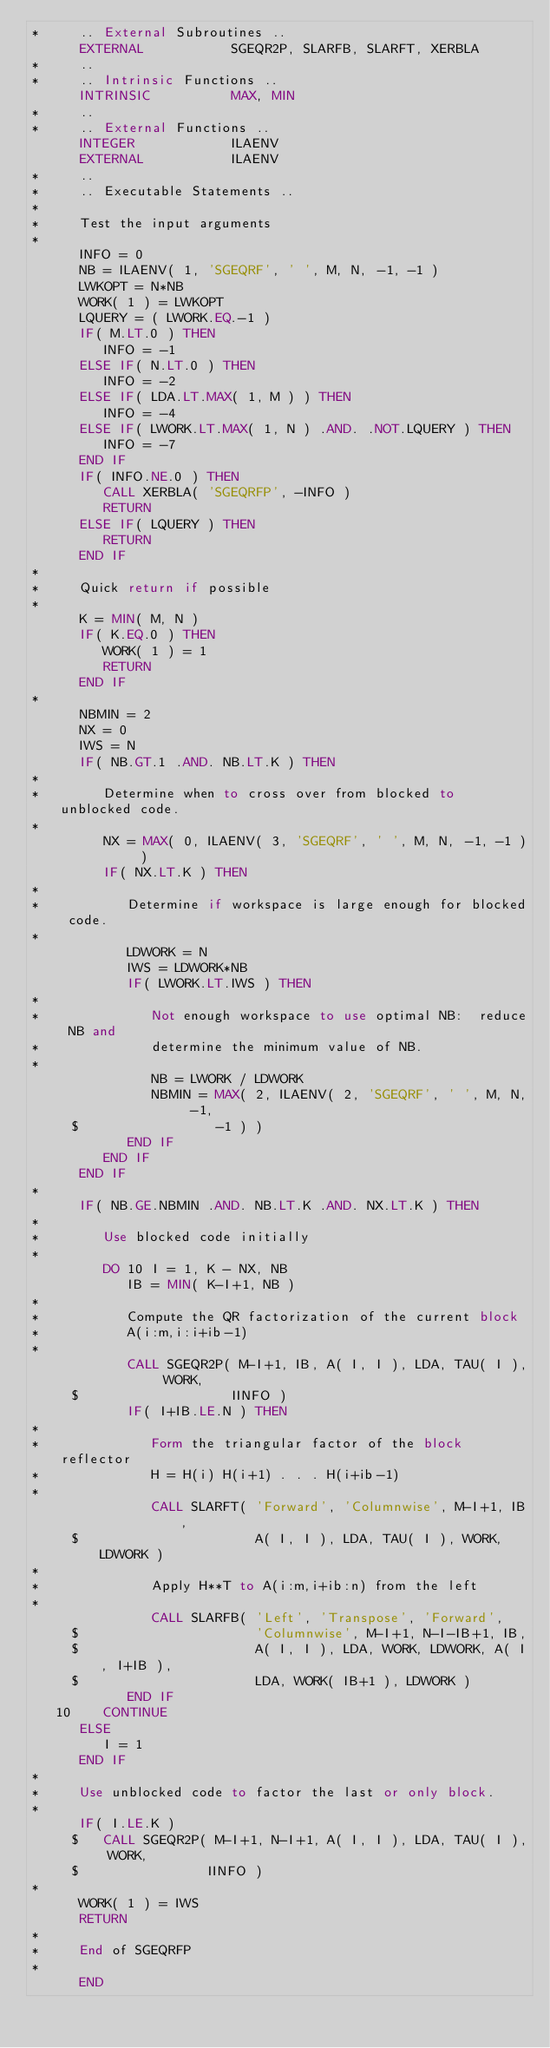<code> <loc_0><loc_0><loc_500><loc_500><_FORTRAN_>*     .. External Subroutines ..
      EXTERNAL           SGEQR2P, SLARFB, SLARFT, XERBLA
*     ..
*     .. Intrinsic Functions ..
      INTRINSIC          MAX, MIN
*     ..
*     .. External Functions ..
      INTEGER            ILAENV
      EXTERNAL           ILAENV
*     ..
*     .. Executable Statements ..
*
*     Test the input arguments
*
      INFO = 0
      NB = ILAENV( 1, 'SGEQRF', ' ', M, N, -1, -1 )
      LWKOPT = N*NB
      WORK( 1 ) = LWKOPT
      LQUERY = ( LWORK.EQ.-1 )
      IF( M.LT.0 ) THEN
         INFO = -1
      ELSE IF( N.LT.0 ) THEN
         INFO = -2
      ELSE IF( LDA.LT.MAX( 1, M ) ) THEN
         INFO = -4
      ELSE IF( LWORK.LT.MAX( 1, N ) .AND. .NOT.LQUERY ) THEN
         INFO = -7
      END IF
      IF( INFO.NE.0 ) THEN
         CALL XERBLA( 'SGEQRFP', -INFO )
         RETURN
      ELSE IF( LQUERY ) THEN
         RETURN
      END IF
*
*     Quick return if possible
*
      K = MIN( M, N )
      IF( K.EQ.0 ) THEN
         WORK( 1 ) = 1
         RETURN
      END IF
*
      NBMIN = 2
      NX = 0
      IWS = N
      IF( NB.GT.1 .AND. NB.LT.K ) THEN
*
*        Determine when to cross over from blocked to unblocked code.
*
         NX = MAX( 0, ILAENV( 3, 'SGEQRF', ' ', M, N, -1, -1 ) )
         IF( NX.LT.K ) THEN
*
*           Determine if workspace is large enough for blocked code.
*
            LDWORK = N
            IWS = LDWORK*NB
            IF( LWORK.LT.IWS ) THEN
*
*              Not enough workspace to use optimal NB:  reduce NB and
*              determine the minimum value of NB.
*
               NB = LWORK / LDWORK
               NBMIN = MAX( 2, ILAENV( 2, 'SGEQRF', ' ', M, N, -1,
     $                 -1 ) )
            END IF
         END IF
      END IF
*
      IF( NB.GE.NBMIN .AND. NB.LT.K .AND. NX.LT.K ) THEN
*
*        Use blocked code initially
*
         DO 10 I = 1, K - NX, NB
            IB = MIN( K-I+1, NB )
*
*           Compute the QR factorization of the current block
*           A(i:m,i:i+ib-1)
*
            CALL SGEQR2P( M-I+1, IB, A( I, I ), LDA, TAU( I ), WORK,
     $                   IINFO )
            IF( I+IB.LE.N ) THEN
*
*              Form the triangular factor of the block reflector
*              H = H(i) H(i+1) . . . H(i+ib-1)
*
               CALL SLARFT( 'Forward', 'Columnwise', M-I+1, IB,
     $                      A( I, I ), LDA, TAU( I ), WORK, LDWORK )
*
*              Apply H**T to A(i:m,i+ib:n) from the left
*
               CALL SLARFB( 'Left', 'Transpose', 'Forward',
     $                      'Columnwise', M-I+1, N-I-IB+1, IB,
     $                      A( I, I ), LDA, WORK, LDWORK, A( I, I+IB ),
     $                      LDA, WORK( IB+1 ), LDWORK )
            END IF
   10    CONTINUE
      ELSE
         I = 1
      END IF
*
*     Use unblocked code to factor the last or only block.
*
      IF( I.LE.K )
     $   CALL SGEQR2P( M-I+1, N-I+1, A( I, I ), LDA, TAU( I ), WORK,
     $                IINFO )
*
      WORK( 1 ) = IWS
      RETURN
*
*     End of SGEQRFP
*
      END
</code> 